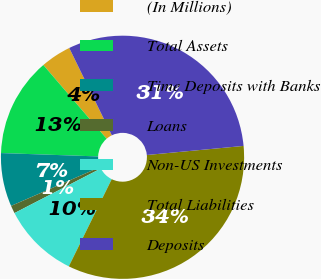<chart> <loc_0><loc_0><loc_500><loc_500><pie_chart><fcel>(In Millions)<fcel>Total Assets<fcel>Time Deposits with Banks<fcel>Loans<fcel>Non-US Investments<fcel>Total Liabilities<fcel>Deposits<nl><fcel>4.07%<fcel>13.16%<fcel>7.1%<fcel>1.04%<fcel>10.13%<fcel>33.77%<fcel>30.73%<nl></chart> 